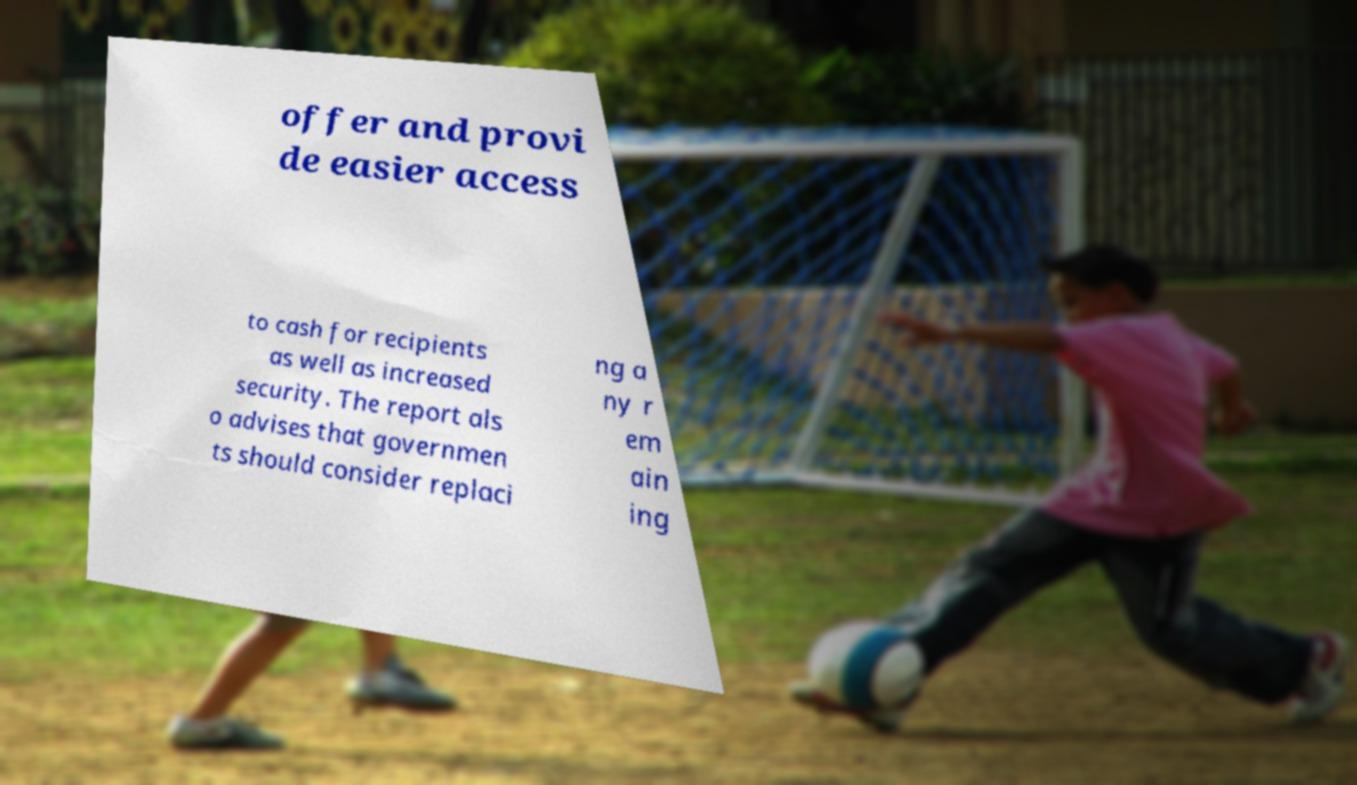Can you read and provide the text displayed in the image?This photo seems to have some interesting text. Can you extract and type it out for me? offer and provi de easier access to cash for recipients as well as increased security. The report als o advises that governmen ts should consider replaci ng a ny r em ain ing 